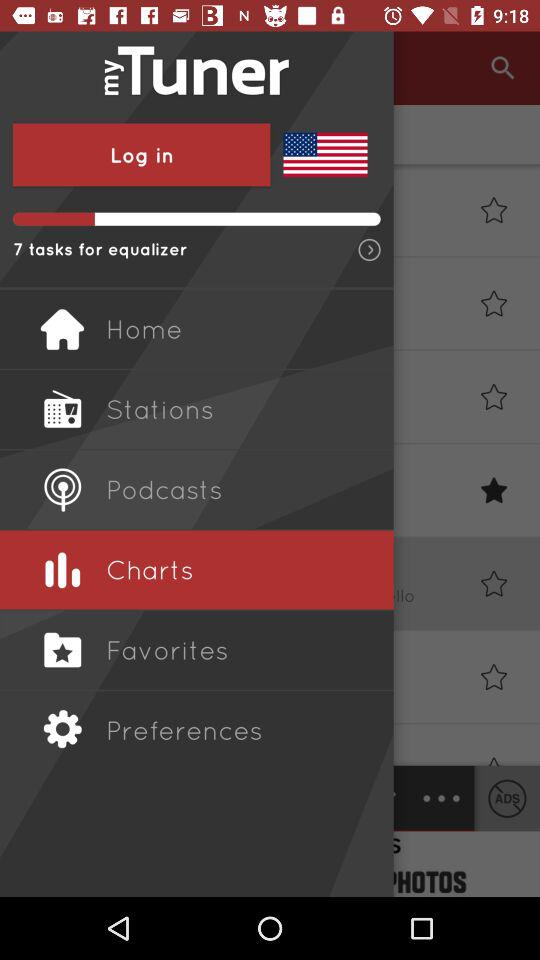What is the count of tasks for the equalizer? The count of tasks for the equalizer is 7. 